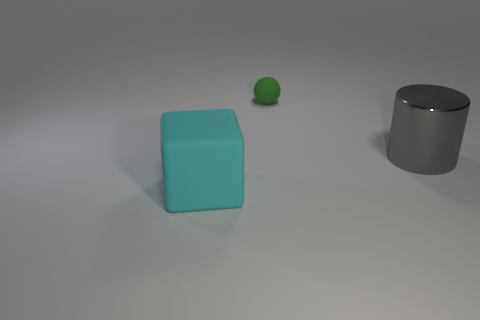Add 2 cyan matte blocks. How many objects exist? 5 Subtract all cylinders. How many objects are left? 2 Add 1 brown cylinders. How many brown cylinders exist? 1 Subtract 0 blue balls. How many objects are left? 3 Subtract all large cyan blocks. Subtract all small matte balls. How many objects are left? 1 Add 2 large metal things. How many large metal things are left? 3 